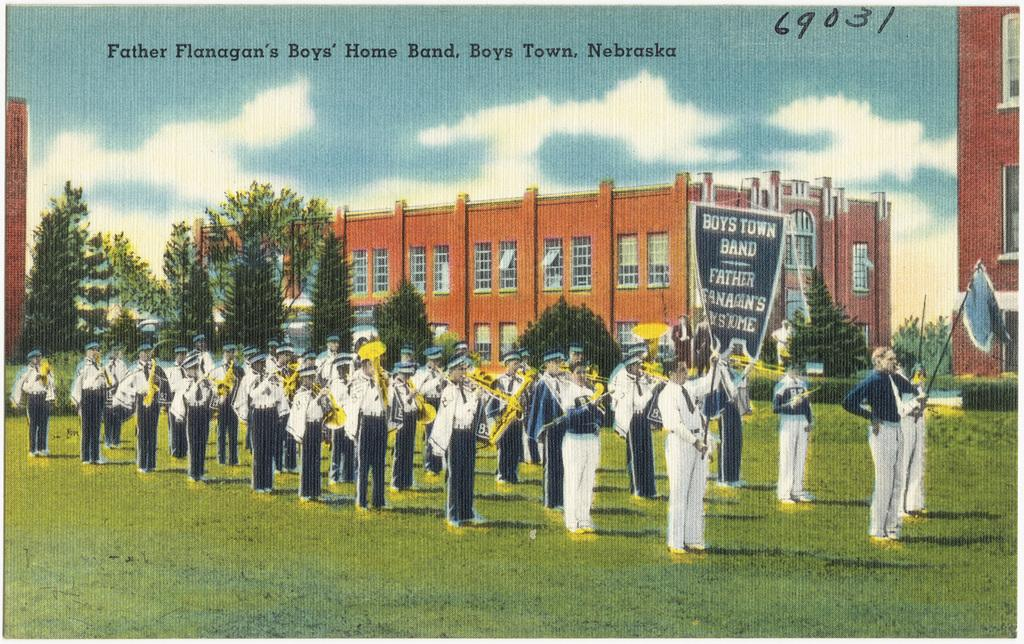<image>
Describe the image concisely. An old picture of a Nebraska marching band. 